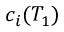<formula> <loc_0><loc_0><loc_500><loc_500>c _ { i } ( T _ { 1 } )</formula> 